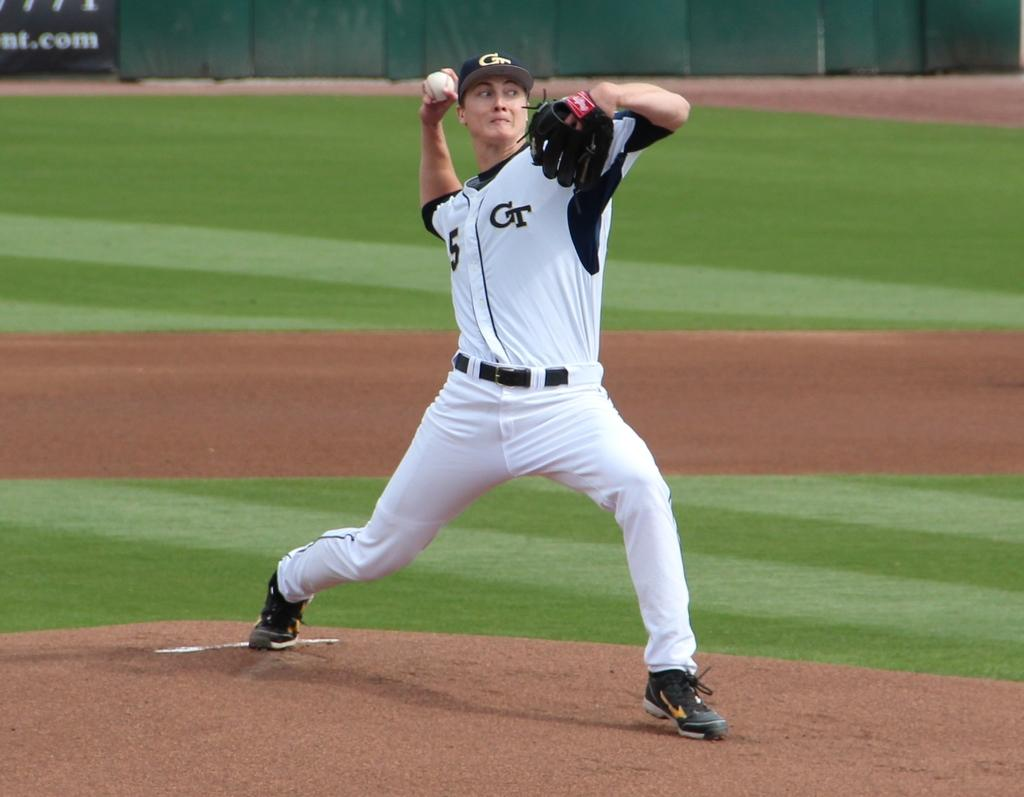<image>
Write a terse but informative summary of the picture. Player number 5 for team GT throws a pitch across the field 